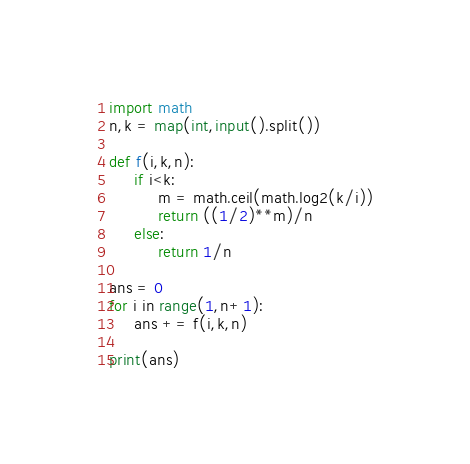Convert code to text. <code><loc_0><loc_0><loc_500><loc_500><_Python_>import math
n,k = map(int,input().split())

def f(i,k,n):
     if i<k:
          m = math.ceil(math.log2(k/i))
          return ((1/2)**m)/n
     else:
          return 1/n

ans = 0
for i in range(1,n+1):
     ans += f(i,k,n)

print(ans)</code> 